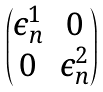<formula> <loc_0><loc_0><loc_500><loc_500>\begin{pmatrix} \epsilon _ { n } ^ { 1 } & 0 \\ 0 & \epsilon _ { n } ^ { 2 } \end{pmatrix}</formula> 